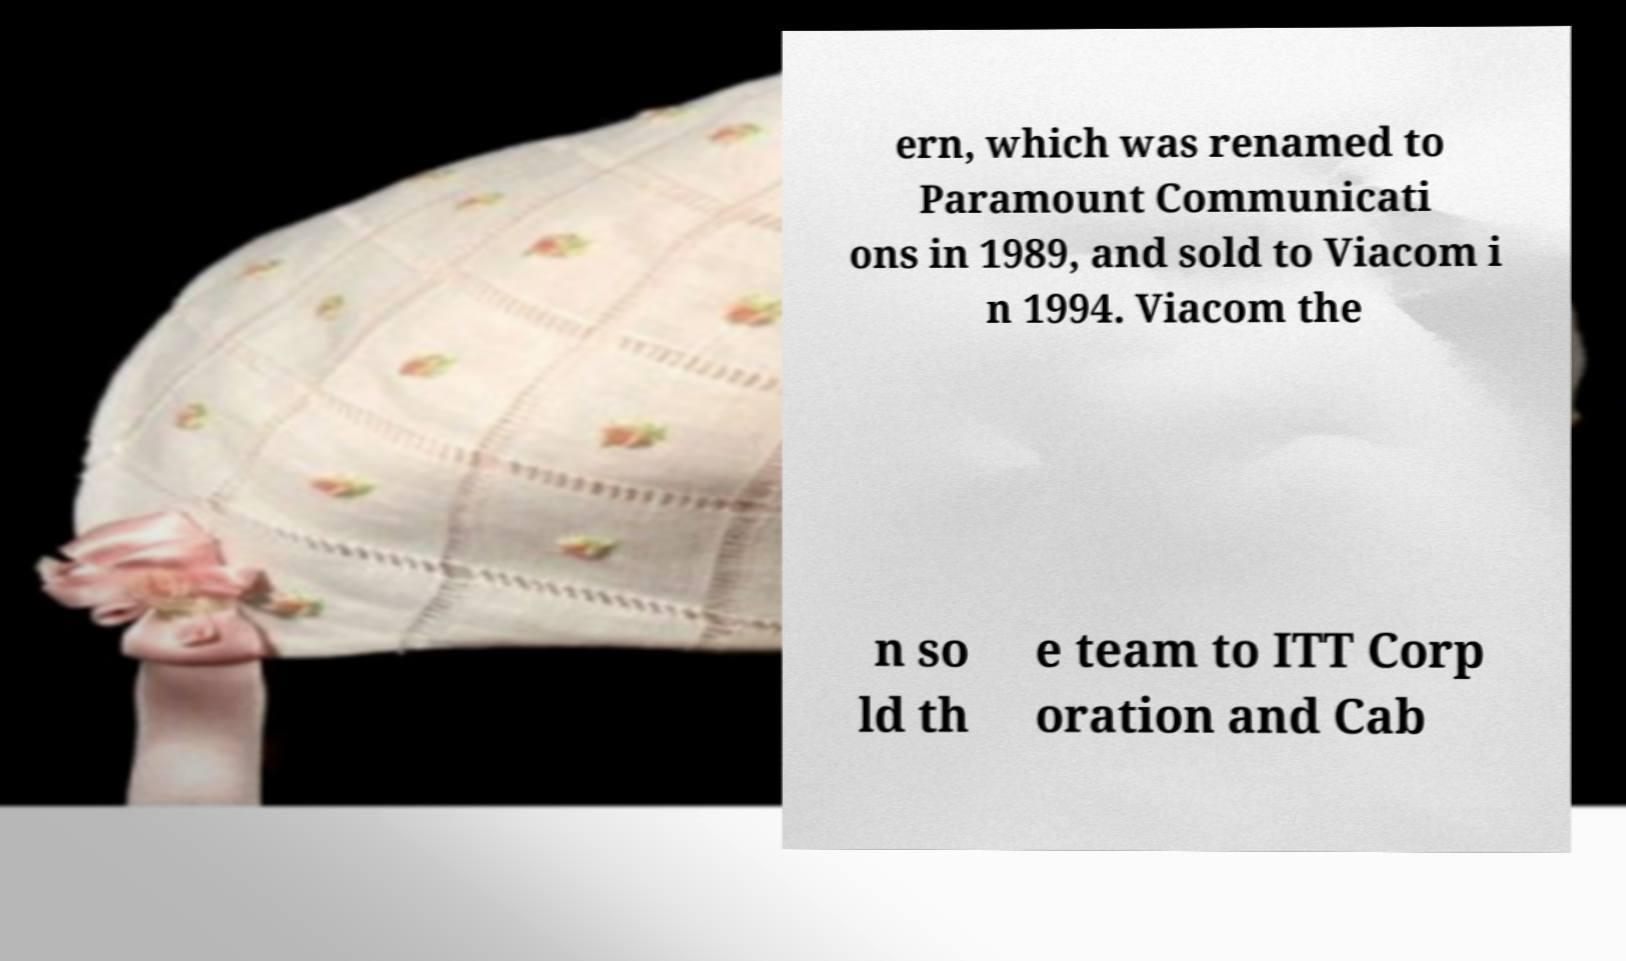Could you extract and type out the text from this image? ern, which was renamed to Paramount Communicati ons in 1989, and sold to Viacom i n 1994. Viacom the n so ld th e team to ITT Corp oration and Cab 